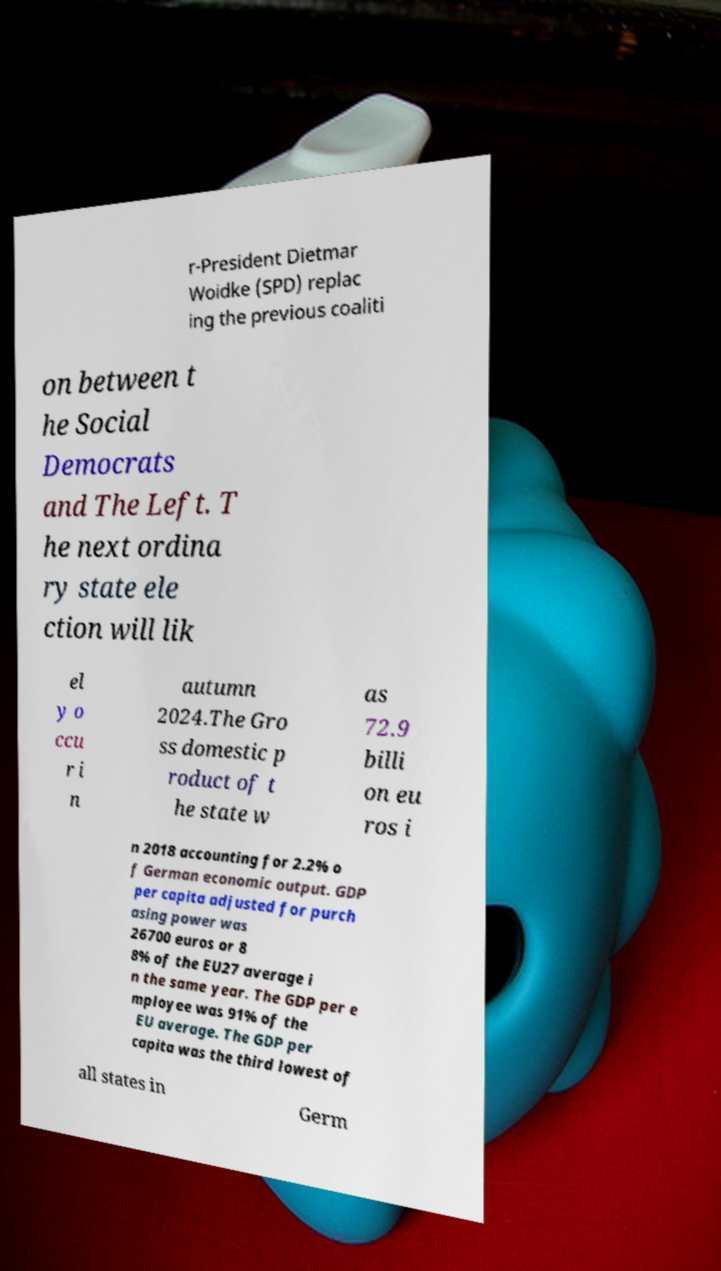For documentation purposes, I need the text within this image transcribed. Could you provide that? r-President Dietmar Woidke (SPD) replac ing the previous coaliti on between t he Social Democrats and The Left. T he next ordina ry state ele ction will lik el y o ccu r i n autumn 2024.The Gro ss domestic p roduct of t he state w as 72.9 billi on eu ros i n 2018 accounting for 2.2% o f German economic output. GDP per capita adjusted for purch asing power was 26700 euros or 8 8% of the EU27 average i n the same year. The GDP per e mployee was 91% of the EU average. The GDP per capita was the third lowest of all states in Germ 